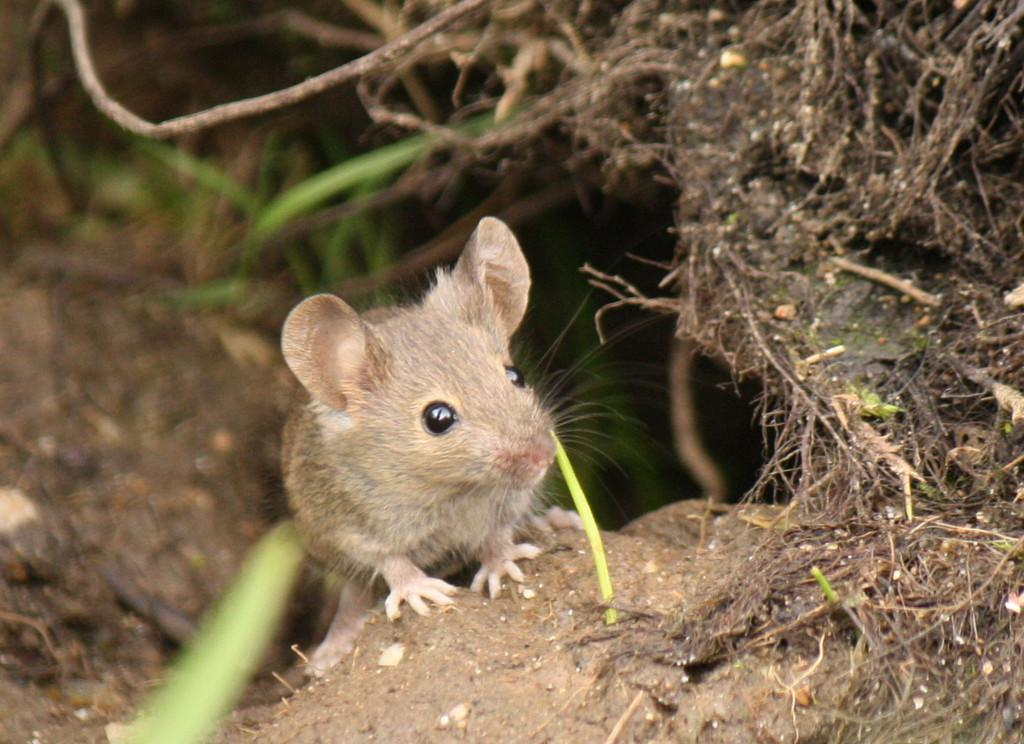What type of animal is present in the image? There is a rat in the image. What type of vegetation can be seen in the image? There is grass in the image. Can you describe the background of the image? The background of the image is blurred. What shape is the ball in the image? There is no ball present in the image. 